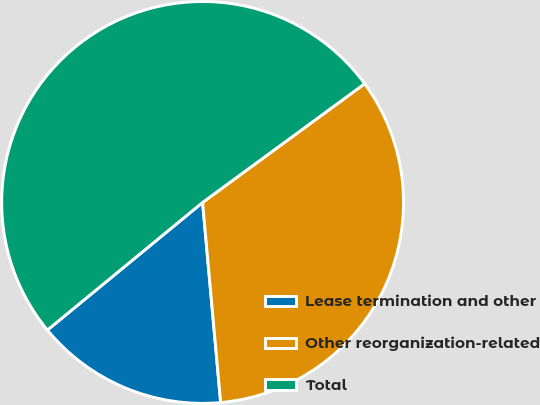Convert chart to OTSL. <chart><loc_0><loc_0><loc_500><loc_500><pie_chart><fcel>Lease termination and other<fcel>Other reorganization-related<fcel>Total<nl><fcel>15.48%<fcel>33.63%<fcel>50.89%<nl></chart> 